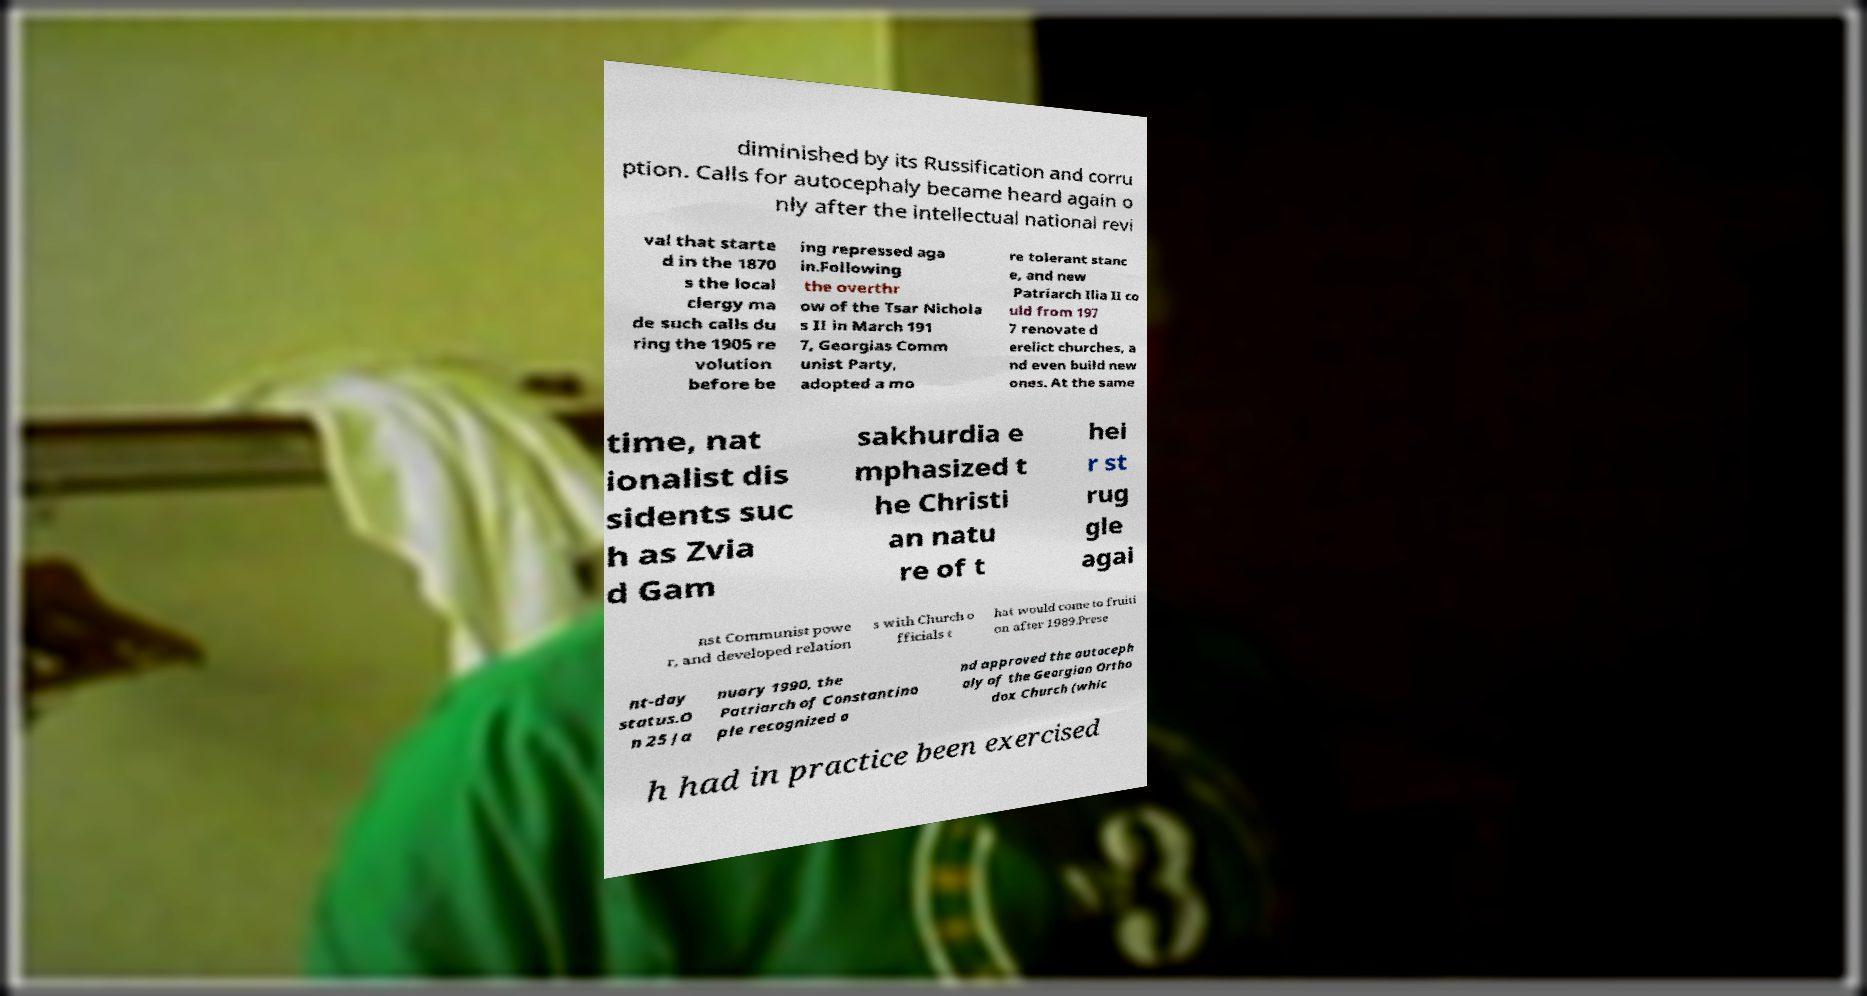I need the written content from this picture converted into text. Can you do that? diminished by its Russification and corru ption. Calls for autocephaly became heard again o nly after the intellectual national revi val that starte d in the 1870 s the local clergy ma de such calls du ring the 1905 re volution before be ing repressed aga in.Following the overthr ow of the Tsar Nichola s II in March 191 7, Georgias Comm unist Party, adopted a mo re tolerant stanc e, and new Patriarch Ilia II co uld from 197 7 renovate d erelict churches, a nd even build new ones. At the same time, nat ionalist dis sidents suc h as Zvia d Gam sakhurdia e mphasized t he Christi an natu re of t hei r st rug gle agai nst Communist powe r, and developed relation s with Church o fficials t hat would come to fruiti on after 1989.Prese nt-day status.O n 25 Ja nuary 1990, the Patriarch of Constantino ple recognized a nd approved the autoceph aly of the Georgian Ortho dox Church (whic h had in practice been exercised 